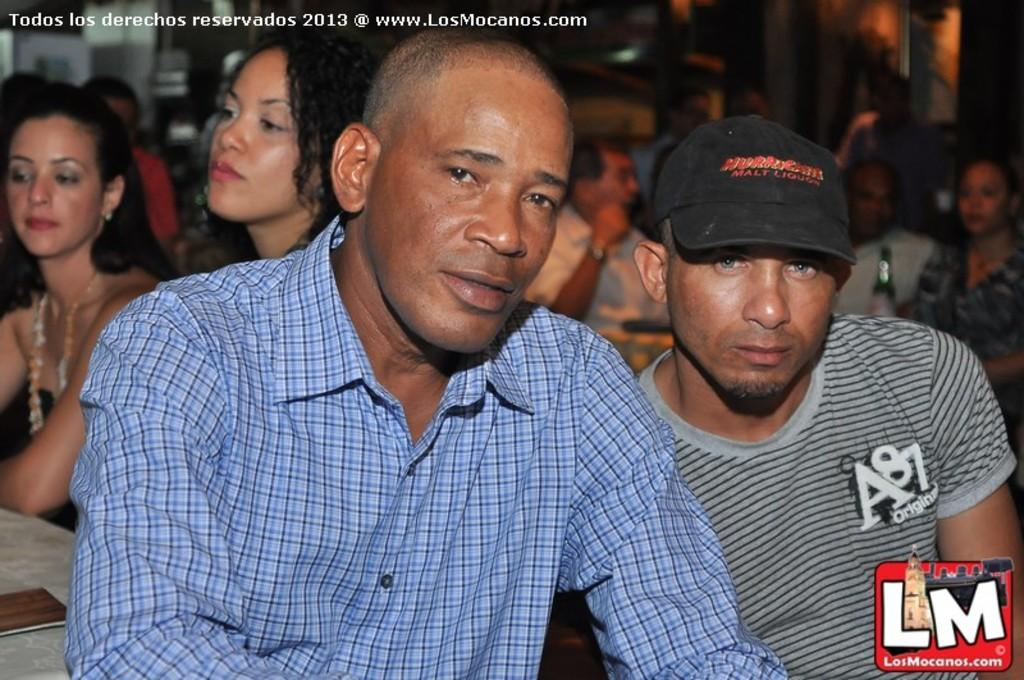What are the people in the image doing? The people in the image are sitting on chairs. What objects are in front of the chairs? Tables are present in front of the chairs. What electronic devices can be seen on the tables? Mobile devices are visible on the tables. What type of beverages might the people be consuming? Beverage bottles are visible on the tables. What type of cloud can be seen in the image? There is no cloud present in the image; it is an indoor setting with people sitting on chairs and tables with mobile devices and beverage bottles. 